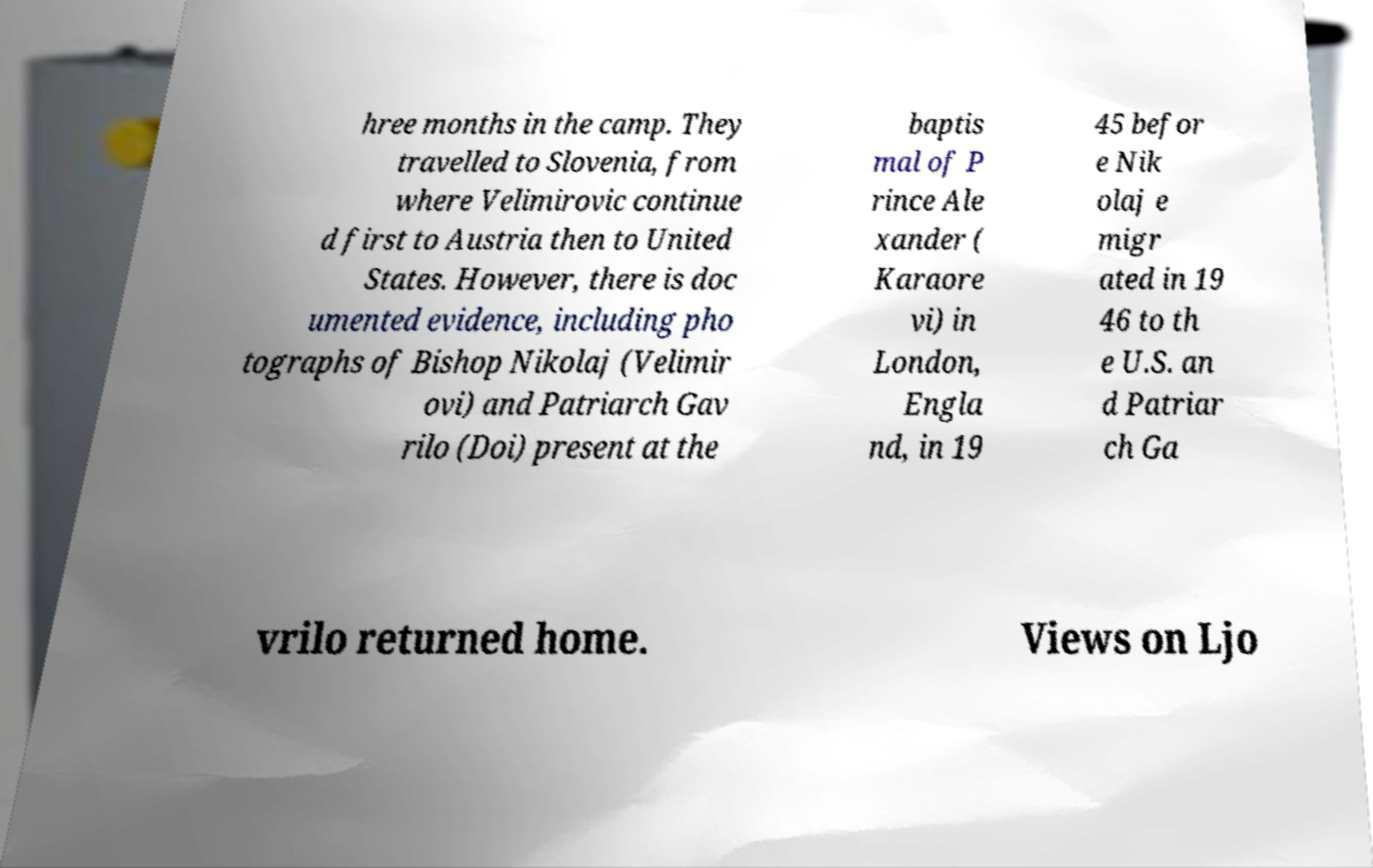There's text embedded in this image that I need extracted. Can you transcribe it verbatim? hree months in the camp. They travelled to Slovenia, from where Velimirovic continue d first to Austria then to United States. However, there is doc umented evidence, including pho tographs of Bishop Nikolaj (Velimir ovi) and Patriarch Gav rilo (Doi) present at the baptis mal of P rince Ale xander ( Karaore vi) in London, Engla nd, in 19 45 befor e Nik olaj e migr ated in 19 46 to th e U.S. an d Patriar ch Ga vrilo returned home. Views on Ljo 